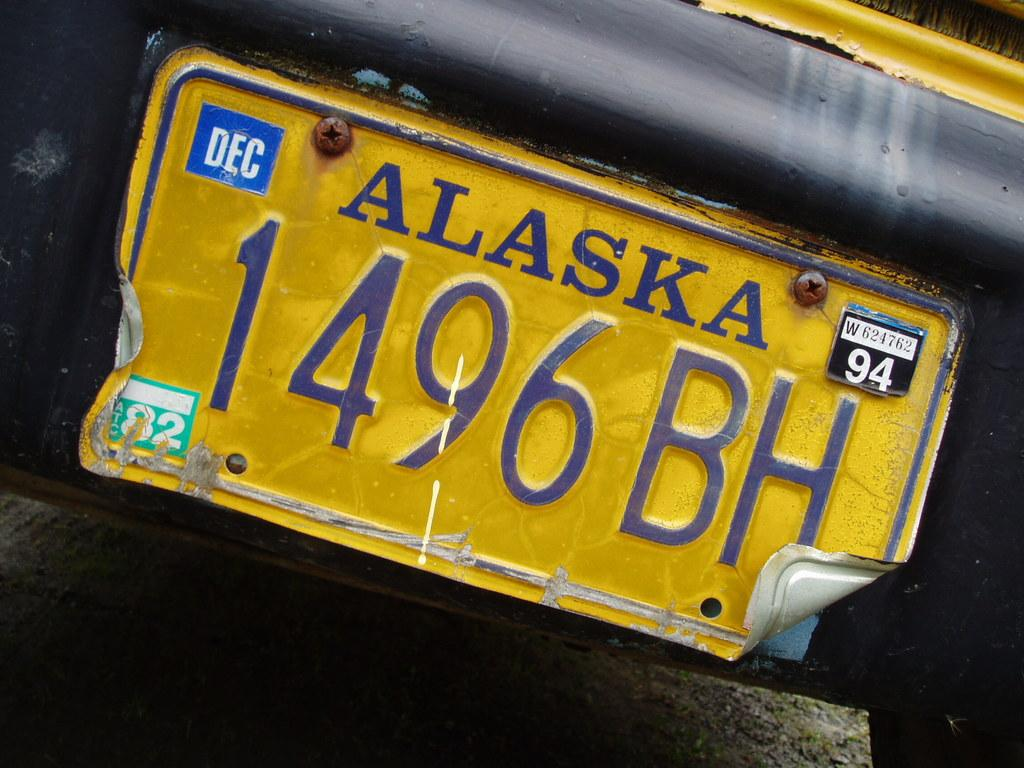<image>
Summarize the visual content of the image. Alaska license plate that says December 94 and has the text 1496 BH. 